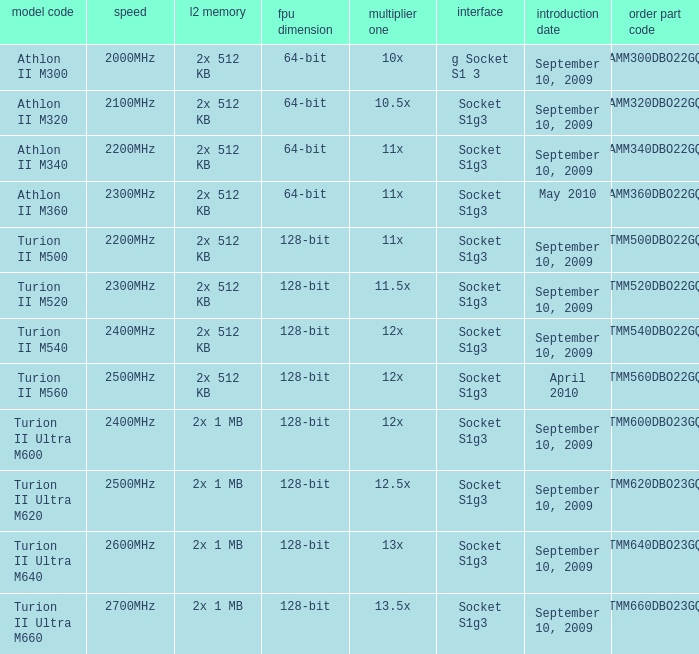Can you give me this table as a dict? {'header': ['model code', 'speed', 'l2 memory', 'fpu dimension', 'multiplier one', 'interface', 'introduction date', 'order part code'], 'rows': [['Athlon II M300', '2000MHz', '2x 512 KB', '64-bit', '10x', 'g Socket S1 3', 'September 10, 2009', 'AMM300DBO22GQ'], ['Athlon II M320', '2100MHz', '2x 512 KB', '64-bit', '10.5x', 'Socket S1g3', 'September 10, 2009', 'AMM320DBO22GQ'], ['Athlon II M340', '2200MHz', '2x 512 KB', '64-bit', '11x', 'Socket S1g3', 'September 10, 2009', 'AMM340DBO22GQ'], ['Athlon II M360', '2300MHz', '2x 512 KB', '64-bit', '11x', 'Socket S1g3', 'May 2010', 'AMM360DBO22GQ'], ['Turion II M500', '2200MHz', '2x 512 KB', '128-bit', '11x', 'Socket S1g3', 'September 10, 2009', 'TMM500DBO22GQ'], ['Turion II M520', '2300MHz', '2x 512 KB', '128-bit', '11.5x', 'Socket S1g3', 'September 10, 2009', 'TMM520DBO22GQ'], ['Turion II M540', '2400MHz', '2x 512 KB', '128-bit', '12x', 'Socket S1g3', 'September 10, 2009', 'TMM540DBO22GQ'], ['Turion II M560', '2500MHz', '2x 512 KB', '128-bit', '12x', 'Socket S1g3', 'April 2010', 'TMM560DBO22GQ'], ['Turion II Ultra M600', '2400MHz', '2x 1 MB', '128-bit', '12x', 'Socket S1g3', 'September 10, 2009', 'TMM600DBO23GQ'], ['Turion II Ultra M620', '2500MHz', '2x 1 MB', '128-bit', '12.5x', 'Socket S1g3', 'September 10, 2009', 'TMM620DBO23GQ'], ['Turion II Ultra M640', '2600MHz', '2x 1 MB', '128-bit', '13x', 'Socket S1g3', 'September 10, 2009', 'TMM640DBO23GQ'], ['Turion II Ultra M660', '2700MHz', '2x 1 MB', '128-bit', '13.5x', 'Socket S1g3', 'September 10, 2009', 'TMM660DBO23GQ']]} What is the L2 cache with a 13.5x multi 1? 2x 1 MB. 